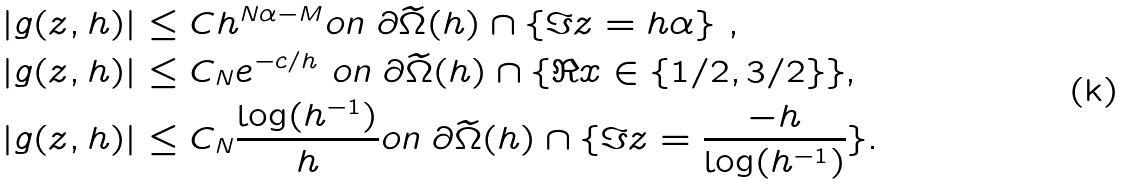Convert formula to latex. <formula><loc_0><loc_0><loc_500><loc_500>| g ( z , h ) | & \leq C h ^ { N \alpha - M } \text {on $\partial \widetilde{\Omega}(h)\cap \{ \Im z = h\alpha \}$ } , \\ | g ( z , h ) | & \leq C _ { N } e ^ { - c / h } \text { on $\partial \widetilde{ \Omega}(h)\cap \{ \Re x \in \{1/2, 3/2\}\}$} , \\ | g ( z , h ) | & \leq C _ { N } \frac { \log ( h ^ { - 1 } ) } h \text {on $\partial \widetilde{\Omega}(h)\cap \{ \Im z = \frac{-h}{ \log(h^{-1})}\}$} .</formula> 